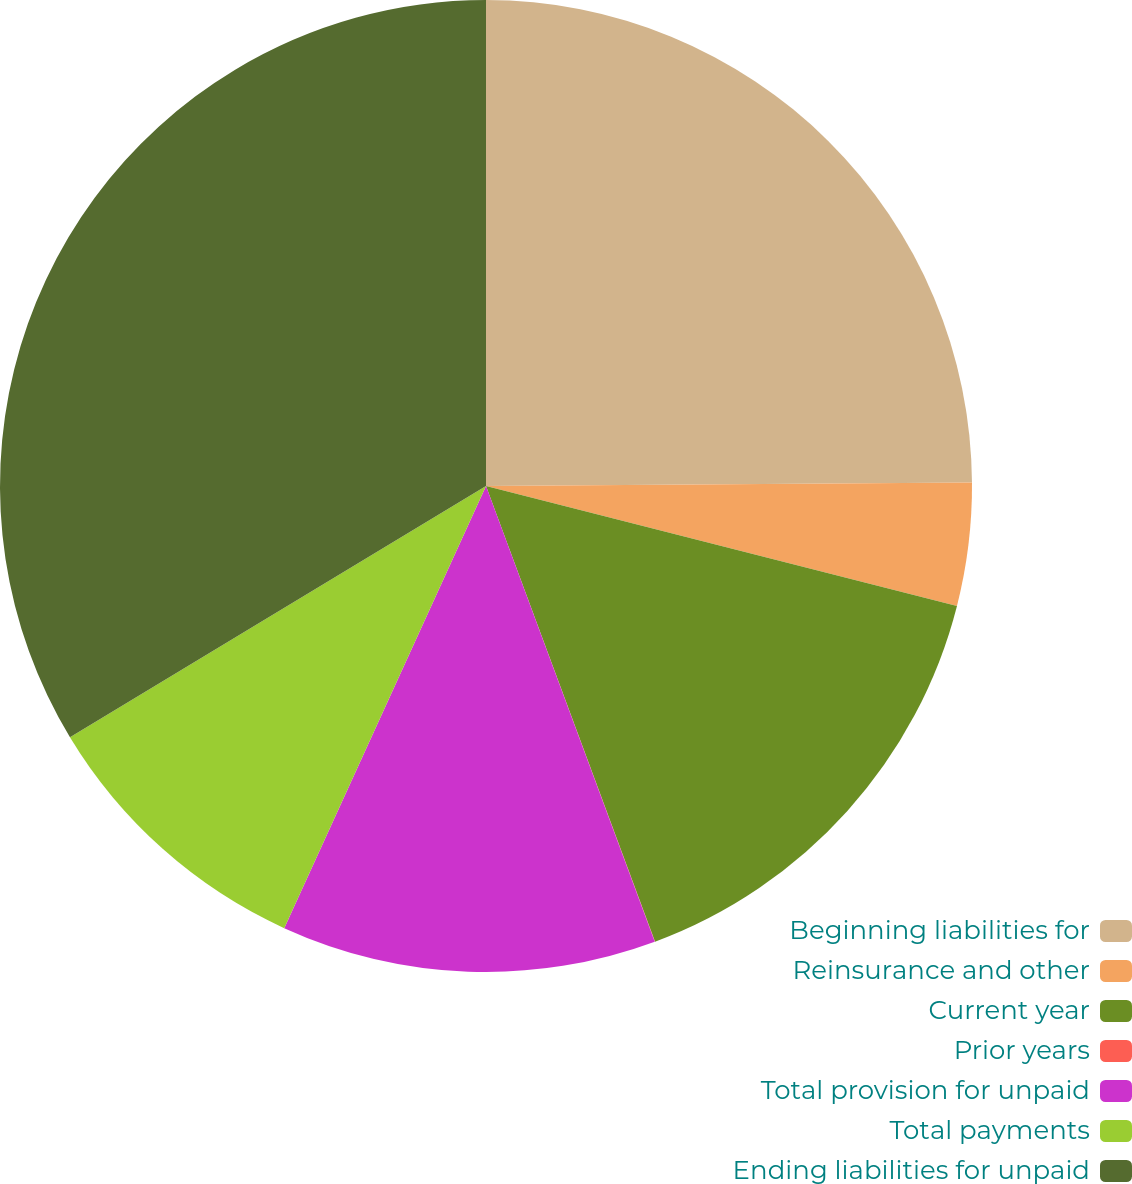<chart> <loc_0><loc_0><loc_500><loc_500><pie_chart><fcel>Beginning liabilities for<fcel>Reinsurance and other<fcel>Current year<fcel>Prior years<fcel>Total provision for unpaid<fcel>Total payments<fcel>Ending liabilities for unpaid<nl><fcel>24.89%<fcel>4.08%<fcel>15.38%<fcel>0.01%<fcel>12.46%<fcel>9.54%<fcel>33.65%<nl></chart> 